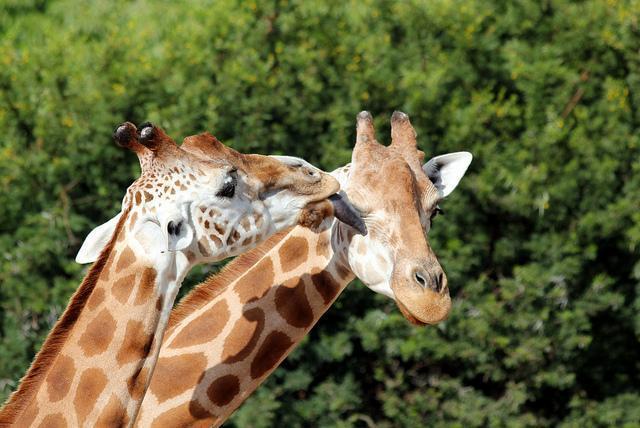How many giraffes are there?
Give a very brief answer. 2. How many bottles of soap are by the sinks?
Give a very brief answer. 0. 